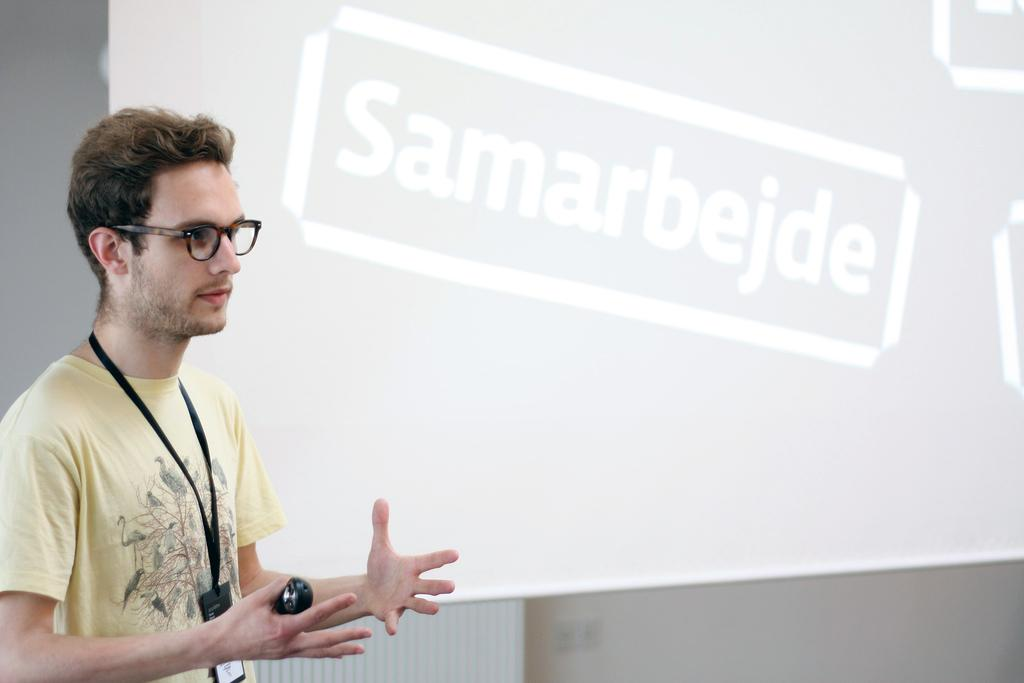What is the main subject of the image? There is a person standing in the image. What is the person holding in the image? The person is holding an object. What can be seen on the screen in the image? There is a screen with text visible in the image. What is in the background of the image? There is a wall in the background of the image. What advice does the person's aunt give in the image's caption? There is no caption present in the image, and therefore no advice from an aunt can be found. 